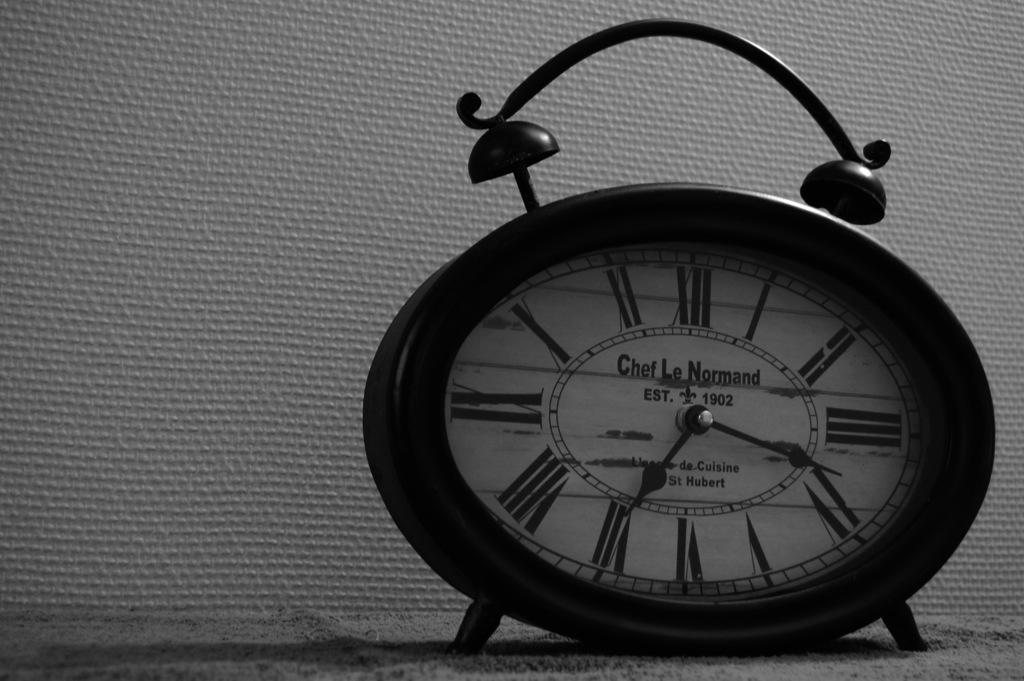Provide a one-sentence caption for the provided image. An old style black alarm clock with roman numerals tells us it is almost 20 past 7. 